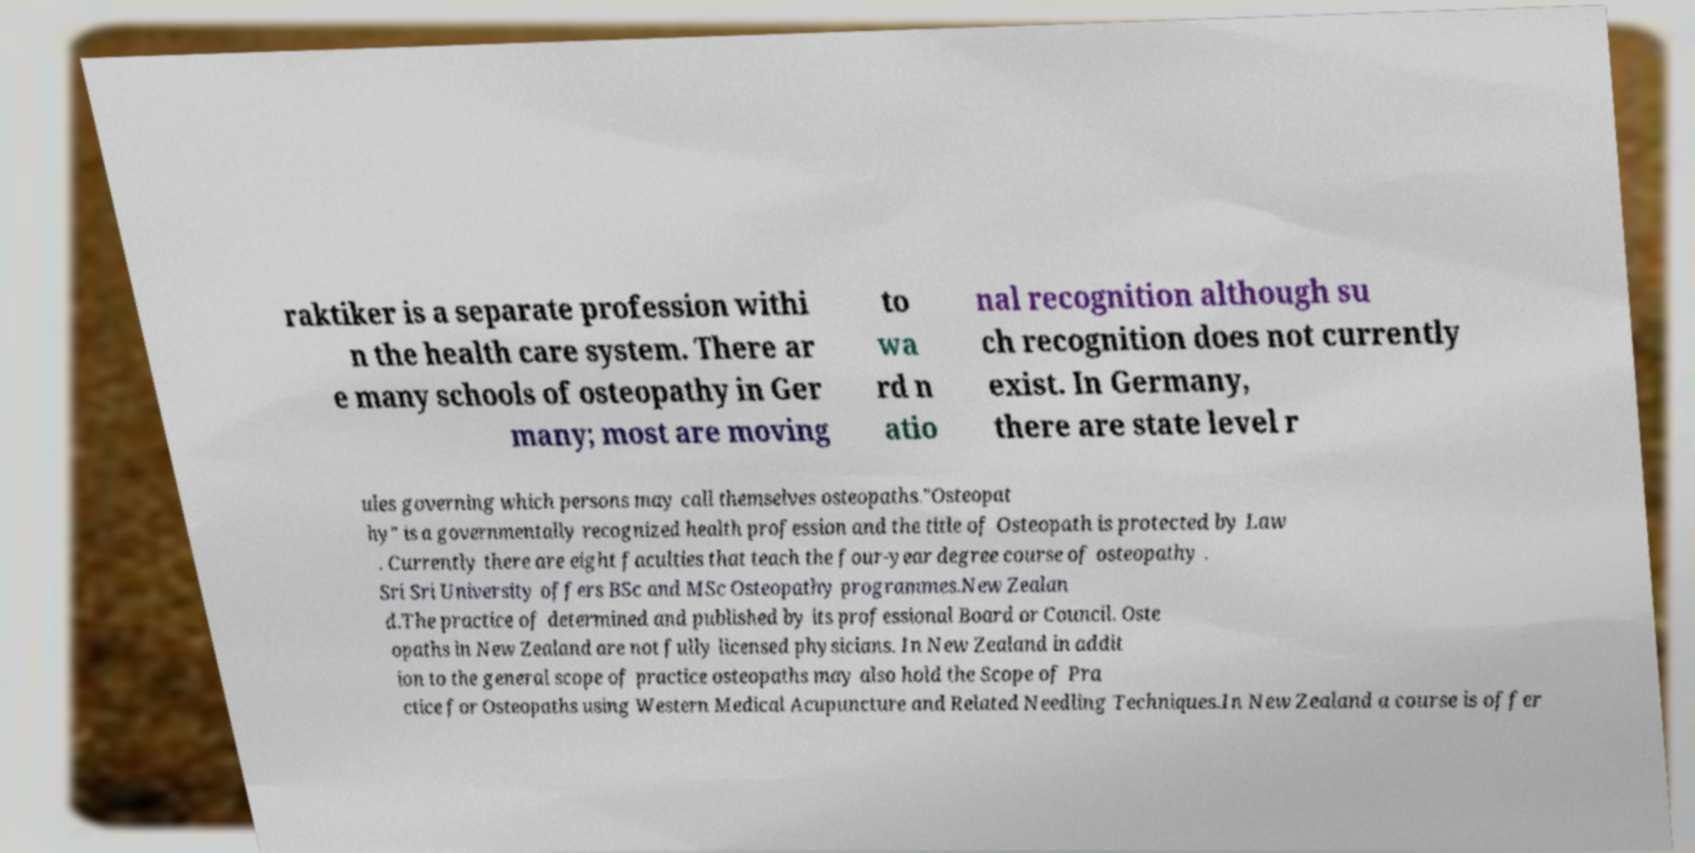Could you assist in decoding the text presented in this image and type it out clearly? raktiker is a separate profession withi n the health care system. There ar e many schools of osteopathy in Ger many; most are moving to wa rd n atio nal recognition although su ch recognition does not currently exist. In Germany, there are state level r ules governing which persons may call themselves osteopaths."Osteopat hy" is a governmentally recognized health profession and the title of Osteopath is protected by Law . Currently there are eight faculties that teach the four-year degree course of osteopathy . Sri Sri University offers BSc and MSc Osteopathy programmes.New Zealan d.The practice of determined and published by its professional Board or Council. Oste opaths in New Zealand are not fully licensed physicians. In New Zealand in addit ion to the general scope of practice osteopaths may also hold the Scope of Pra ctice for Osteopaths using Western Medical Acupuncture and Related Needling Techniques.In New Zealand a course is offer 